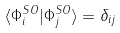<formula> <loc_0><loc_0><loc_500><loc_500>\langle \Phi _ { i } ^ { S O } | \Phi _ { j } ^ { S O } \rangle = \delta _ { i j }</formula> 